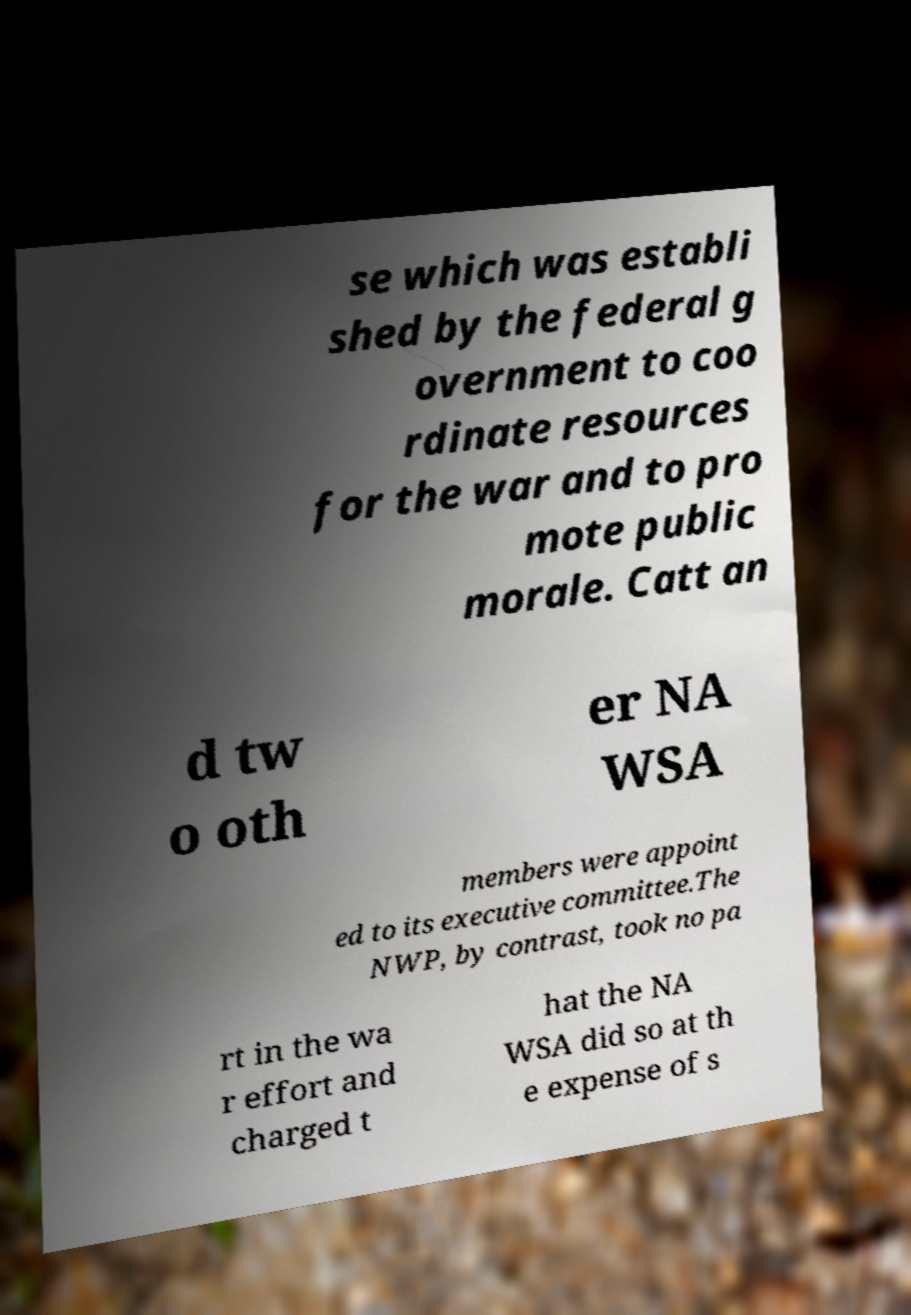I need the written content from this picture converted into text. Can you do that? se which was establi shed by the federal g overnment to coo rdinate resources for the war and to pro mote public morale. Catt an d tw o oth er NA WSA members were appoint ed to its executive committee.The NWP, by contrast, took no pa rt in the wa r effort and charged t hat the NA WSA did so at th e expense of s 